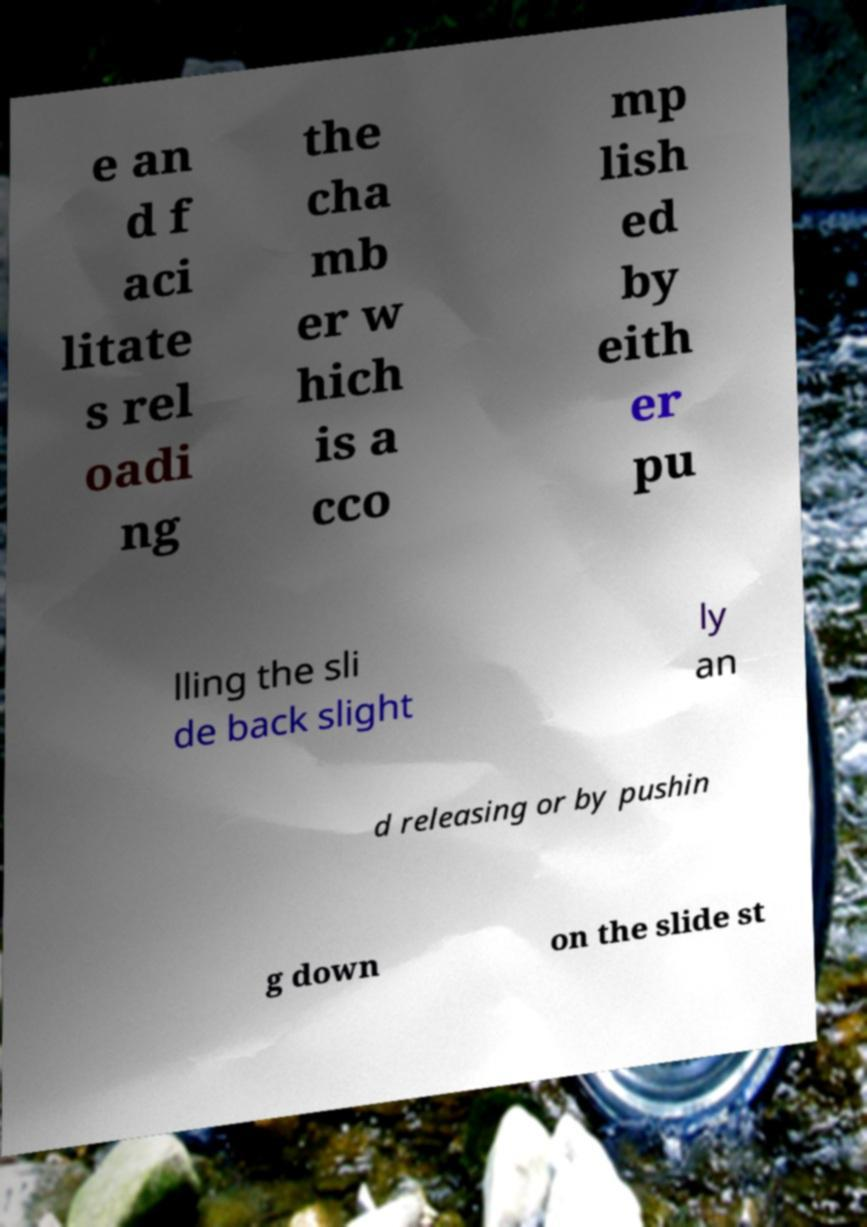Can you accurately transcribe the text from the provided image for me? e an d f aci litate s rel oadi ng the cha mb er w hich is a cco mp lish ed by eith er pu lling the sli de back slight ly an d releasing or by pushin g down on the slide st 